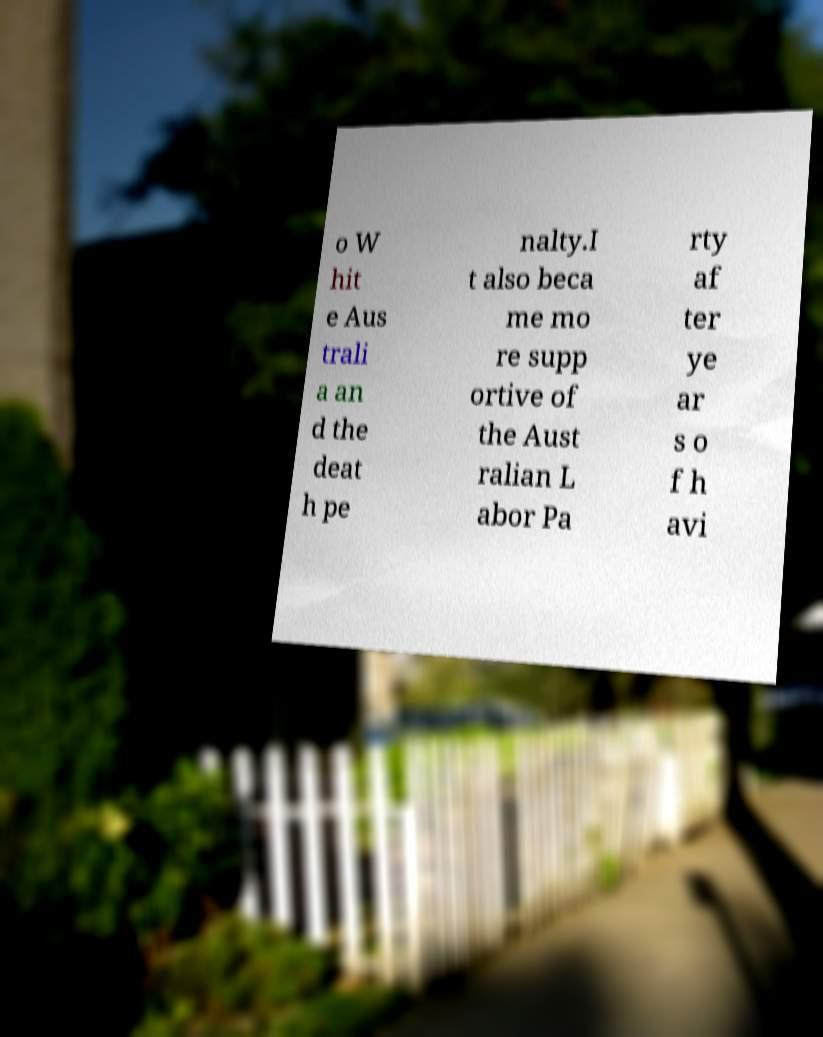Can you accurately transcribe the text from the provided image for me? o W hit e Aus trali a an d the deat h pe nalty.I t also beca me mo re supp ortive of the Aust ralian L abor Pa rty af ter ye ar s o f h avi 